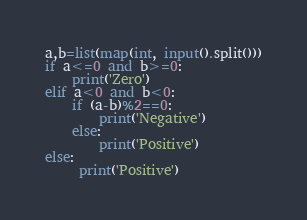<code> <loc_0><loc_0><loc_500><loc_500><_Python_>a,b=list(map(int, input().split()))
if a<=0 and b>=0:
    print('Zero')
elif a<0 and b<0:
    if (a-b)%2==0:
        print('Negative')
    else:
        print('Positive')
else:
     print('Positive')</code> 